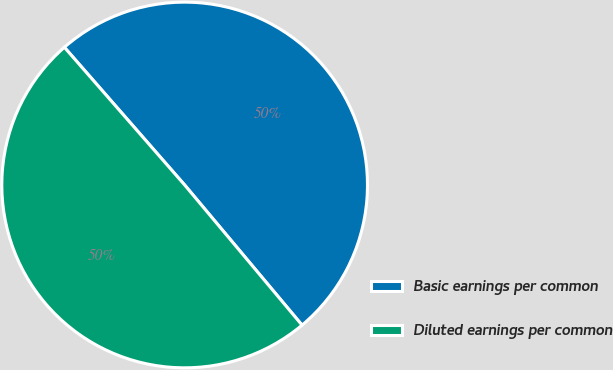<chart> <loc_0><loc_0><loc_500><loc_500><pie_chart><fcel>Basic earnings per common<fcel>Diluted earnings per common<nl><fcel>50.33%<fcel>49.67%<nl></chart> 